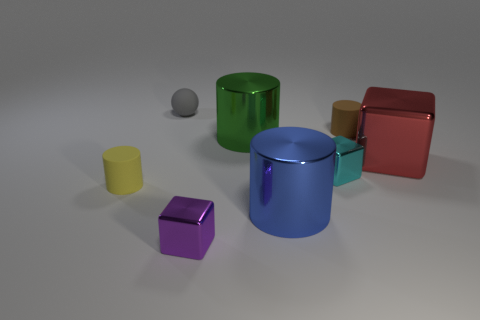How many other things are the same size as the brown object?
Your answer should be compact. 4. Do the yellow object and the shiny cylinder that is in front of the cyan shiny thing have the same size?
Provide a succinct answer. No. There is a block that is the same size as the blue metallic thing; what color is it?
Your answer should be compact. Red. The cyan object has what size?
Offer a very short reply. Small. Is the thing that is behind the tiny brown rubber cylinder made of the same material as the blue cylinder?
Your answer should be compact. No. Do the blue metal thing and the small purple metal thing have the same shape?
Make the answer very short. No. What shape is the tiny rubber object in front of the cube that is right of the tiny cylinder that is right of the tiny cyan thing?
Give a very brief answer. Cylinder. Is the shape of the small matte object that is to the right of the purple thing the same as the small metal object that is right of the blue cylinder?
Offer a very short reply. No. Is there a small brown block made of the same material as the blue cylinder?
Your answer should be compact. No. What color is the matte object on the right side of the cube that is in front of the cylinder that is left of the large green cylinder?
Offer a very short reply. Brown. 